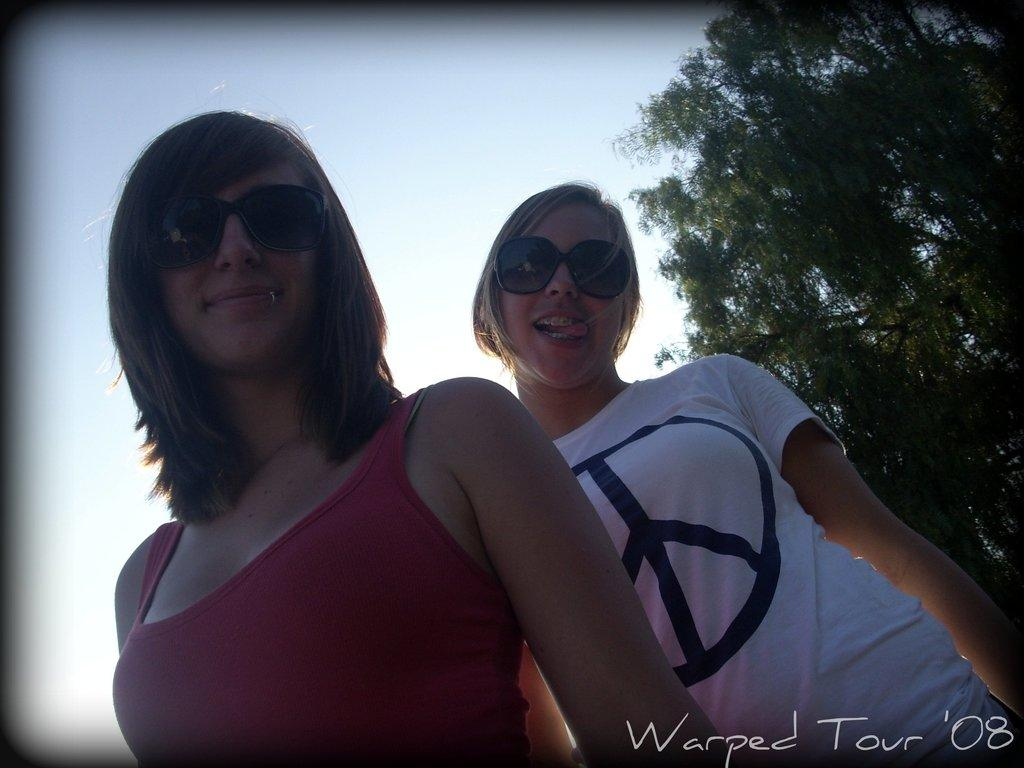How many people are in total are in the image? There are two people in the image. What colors are the dresses of the people in the image? One person is wearing a red dress, and the other is wearing a white dress. What protective gear are the people wearing? Both people are wearing goggles. What can be seen to the right of the image? There is a tree to the right of the image. What is visible in the background of the image? The sky is visible in the background of the image. Can you tell me how many balls are being juggled by the person in the red dress? There are no balls present in the image; the people are wearing goggles, but there is no indication of any juggling activity. 